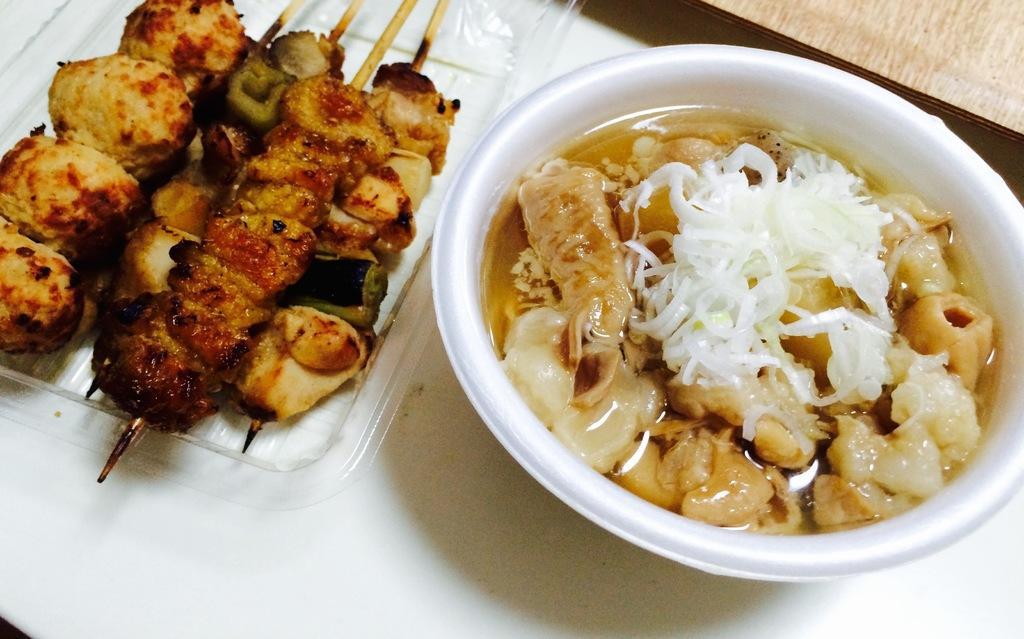How would you summarize this image in a sentence or two? In this image, I can see a tray of brochette and a bowl are placed on the table. This bowl contains of soup, meat and few other ingredients in it. 